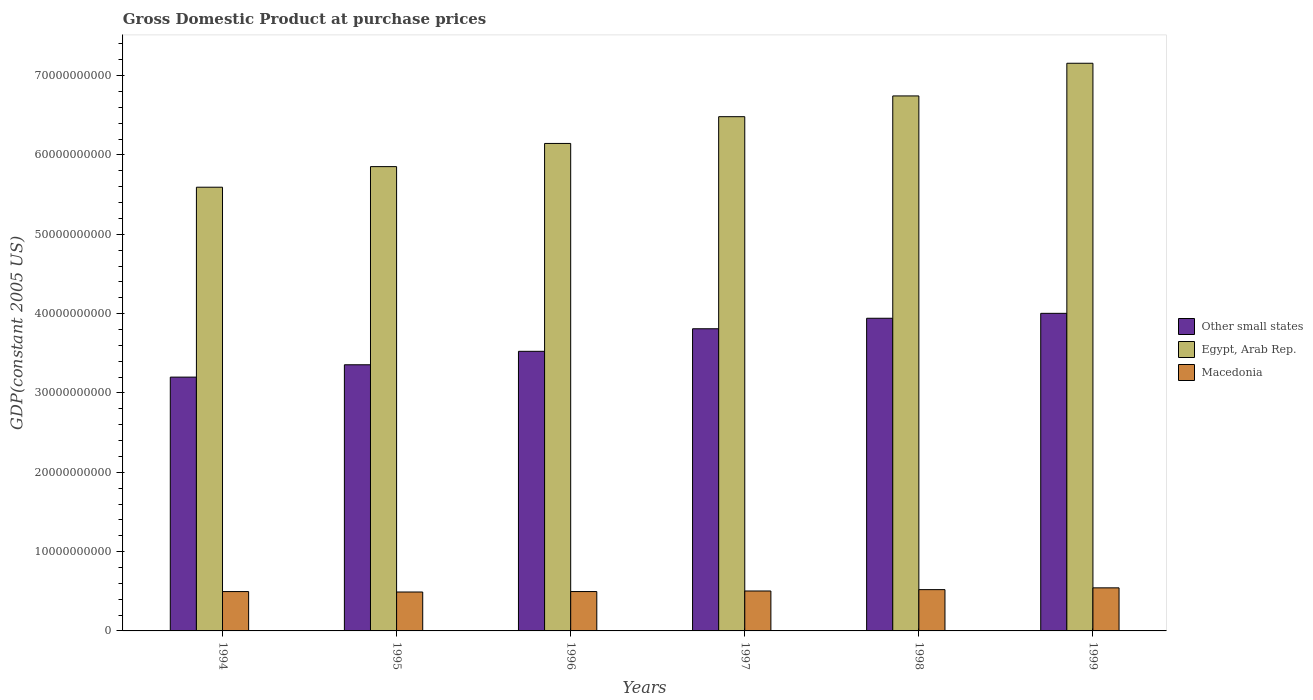How many different coloured bars are there?
Ensure brevity in your answer.  3. How many bars are there on the 3rd tick from the right?
Provide a short and direct response. 3. What is the label of the 4th group of bars from the left?
Keep it short and to the point. 1997. What is the GDP at purchase prices in Macedonia in 1999?
Offer a terse response. 5.43e+09. Across all years, what is the maximum GDP at purchase prices in Macedonia?
Give a very brief answer. 5.43e+09. Across all years, what is the minimum GDP at purchase prices in Other small states?
Give a very brief answer. 3.20e+1. In which year was the GDP at purchase prices in Macedonia minimum?
Keep it short and to the point. 1995. What is the total GDP at purchase prices in Macedonia in the graph?
Give a very brief answer. 3.05e+1. What is the difference between the GDP at purchase prices in Other small states in 1995 and that in 1996?
Provide a succinct answer. -1.70e+09. What is the difference between the GDP at purchase prices in Macedonia in 1999 and the GDP at purchase prices in Other small states in 1994?
Keep it short and to the point. -2.66e+1. What is the average GDP at purchase prices in Egypt, Arab Rep. per year?
Your answer should be compact. 6.33e+1. In the year 1998, what is the difference between the GDP at purchase prices in Macedonia and GDP at purchase prices in Other small states?
Offer a very short reply. -3.42e+1. In how many years, is the GDP at purchase prices in Macedonia greater than 66000000000 US$?
Ensure brevity in your answer.  0. What is the ratio of the GDP at purchase prices in Other small states in 1998 to that in 1999?
Make the answer very short. 0.98. Is the difference between the GDP at purchase prices in Macedonia in 1996 and 1998 greater than the difference between the GDP at purchase prices in Other small states in 1996 and 1998?
Provide a succinct answer. Yes. What is the difference between the highest and the second highest GDP at purchase prices in Egypt, Arab Rep.?
Give a very brief answer. 4.12e+09. What is the difference between the highest and the lowest GDP at purchase prices in Egypt, Arab Rep.?
Provide a succinct answer. 1.56e+1. What does the 1st bar from the left in 1995 represents?
Your response must be concise. Other small states. What does the 3rd bar from the right in 1995 represents?
Your answer should be compact. Other small states. Are all the bars in the graph horizontal?
Provide a short and direct response. No. How many years are there in the graph?
Give a very brief answer. 6. What is the difference between two consecutive major ticks on the Y-axis?
Provide a short and direct response. 1.00e+1. Are the values on the major ticks of Y-axis written in scientific E-notation?
Make the answer very short. No. Does the graph contain any zero values?
Your response must be concise. No. Where does the legend appear in the graph?
Offer a very short reply. Center right. How many legend labels are there?
Provide a succinct answer. 3. How are the legend labels stacked?
Your response must be concise. Vertical. What is the title of the graph?
Provide a short and direct response. Gross Domestic Product at purchase prices. Does "Cameroon" appear as one of the legend labels in the graph?
Provide a succinct answer. No. What is the label or title of the Y-axis?
Ensure brevity in your answer.  GDP(constant 2005 US). What is the GDP(constant 2005 US) of Other small states in 1994?
Offer a very short reply. 3.20e+1. What is the GDP(constant 2005 US) of Egypt, Arab Rep. in 1994?
Provide a short and direct response. 5.59e+1. What is the GDP(constant 2005 US) of Macedonia in 1994?
Your answer should be very brief. 4.96e+09. What is the GDP(constant 2005 US) in Other small states in 1995?
Provide a short and direct response. 3.36e+1. What is the GDP(constant 2005 US) of Egypt, Arab Rep. in 1995?
Ensure brevity in your answer.  5.85e+1. What is the GDP(constant 2005 US) of Macedonia in 1995?
Provide a succinct answer. 4.90e+09. What is the GDP(constant 2005 US) of Other small states in 1996?
Offer a very short reply. 3.52e+1. What is the GDP(constant 2005 US) of Egypt, Arab Rep. in 1996?
Offer a very short reply. 6.15e+1. What is the GDP(constant 2005 US) in Macedonia in 1996?
Make the answer very short. 4.96e+09. What is the GDP(constant 2005 US) of Other small states in 1997?
Keep it short and to the point. 3.81e+1. What is the GDP(constant 2005 US) of Egypt, Arab Rep. in 1997?
Provide a short and direct response. 6.48e+1. What is the GDP(constant 2005 US) of Macedonia in 1997?
Offer a terse response. 5.03e+09. What is the GDP(constant 2005 US) in Other small states in 1998?
Give a very brief answer. 3.94e+1. What is the GDP(constant 2005 US) of Egypt, Arab Rep. in 1998?
Keep it short and to the point. 6.74e+1. What is the GDP(constant 2005 US) of Macedonia in 1998?
Keep it short and to the point. 5.20e+09. What is the GDP(constant 2005 US) of Other small states in 1999?
Keep it short and to the point. 4.00e+1. What is the GDP(constant 2005 US) of Egypt, Arab Rep. in 1999?
Your answer should be compact. 7.16e+1. What is the GDP(constant 2005 US) of Macedonia in 1999?
Make the answer very short. 5.43e+09. Across all years, what is the maximum GDP(constant 2005 US) in Other small states?
Provide a short and direct response. 4.00e+1. Across all years, what is the maximum GDP(constant 2005 US) in Egypt, Arab Rep.?
Provide a short and direct response. 7.16e+1. Across all years, what is the maximum GDP(constant 2005 US) in Macedonia?
Provide a succinct answer. 5.43e+09. Across all years, what is the minimum GDP(constant 2005 US) of Other small states?
Offer a very short reply. 3.20e+1. Across all years, what is the minimum GDP(constant 2005 US) in Egypt, Arab Rep.?
Provide a short and direct response. 5.59e+1. Across all years, what is the minimum GDP(constant 2005 US) of Macedonia?
Give a very brief answer. 4.90e+09. What is the total GDP(constant 2005 US) in Other small states in the graph?
Provide a short and direct response. 2.18e+11. What is the total GDP(constant 2005 US) in Egypt, Arab Rep. in the graph?
Your answer should be very brief. 3.80e+11. What is the total GDP(constant 2005 US) of Macedonia in the graph?
Offer a very short reply. 3.05e+1. What is the difference between the GDP(constant 2005 US) of Other small states in 1994 and that in 1995?
Provide a succinct answer. -1.56e+09. What is the difference between the GDP(constant 2005 US) in Egypt, Arab Rep. in 1994 and that in 1995?
Your answer should be compact. -2.60e+09. What is the difference between the GDP(constant 2005 US) of Macedonia in 1994 and that in 1995?
Keep it short and to the point. 5.53e+07. What is the difference between the GDP(constant 2005 US) of Other small states in 1994 and that in 1996?
Your response must be concise. -3.25e+09. What is the difference between the GDP(constant 2005 US) of Egypt, Arab Rep. in 1994 and that in 1996?
Offer a very short reply. -5.52e+09. What is the difference between the GDP(constant 2005 US) of Macedonia in 1994 and that in 1996?
Give a very brief answer. -2.84e+06. What is the difference between the GDP(constant 2005 US) in Other small states in 1994 and that in 1997?
Ensure brevity in your answer.  -6.10e+09. What is the difference between the GDP(constant 2005 US) in Egypt, Arab Rep. in 1994 and that in 1997?
Your answer should be very brief. -8.89e+09. What is the difference between the GDP(constant 2005 US) of Macedonia in 1994 and that in 1997?
Give a very brief answer. -7.43e+07. What is the difference between the GDP(constant 2005 US) in Other small states in 1994 and that in 1998?
Your response must be concise. -7.42e+09. What is the difference between the GDP(constant 2005 US) in Egypt, Arab Rep. in 1994 and that in 1998?
Provide a short and direct response. -1.15e+1. What is the difference between the GDP(constant 2005 US) of Macedonia in 1994 and that in 1998?
Keep it short and to the point. -2.44e+08. What is the difference between the GDP(constant 2005 US) of Other small states in 1994 and that in 1999?
Make the answer very short. -8.04e+09. What is the difference between the GDP(constant 2005 US) of Egypt, Arab Rep. in 1994 and that in 1999?
Your answer should be very brief. -1.56e+1. What is the difference between the GDP(constant 2005 US) in Macedonia in 1994 and that in 1999?
Offer a terse response. -4.70e+08. What is the difference between the GDP(constant 2005 US) in Other small states in 1995 and that in 1996?
Make the answer very short. -1.70e+09. What is the difference between the GDP(constant 2005 US) of Egypt, Arab Rep. in 1995 and that in 1996?
Provide a succinct answer. -2.92e+09. What is the difference between the GDP(constant 2005 US) of Macedonia in 1995 and that in 1996?
Offer a very short reply. -5.81e+07. What is the difference between the GDP(constant 2005 US) in Other small states in 1995 and that in 1997?
Your response must be concise. -4.54e+09. What is the difference between the GDP(constant 2005 US) of Egypt, Arab Rep. in 1995 and that in 1997?
Ensure brevity in your answer.  -6.29e+09. What is the difference between the GDP(constant 2005 US) of Macedonia in 1995 and that in 1997?
Offer a terse response. -1.30e+08. What is the difference between the GDP(constant 2005 US) in Other small states in 1995 and that in 1998?
Offer a very short reply. -5.86e+09. What is the difference between the GDP(constant 2005 US) of Egypt, Arab Rep. in 1995 and that in 1998?
Make the answer very short. -8.91e+09. What is the difference between the GDP(constant 2005 US) in Macedonia in 1995 and that in 1998?
Offer a terse response. -3.00e+08. What is the difference between the GDP(constant 2005 US) in Other small states in 1995 and that in 1999?
Provide a short and direct response. -6.48e+09. What is the difference between the GDP(constant 2005 US) in Egypt, Arab Rep. in 1995 and that in 1999?
Make the answer very short. -1.30e+1. What is the difference between the GDP(constant 2005 US) in Macedonia in 1995 and that in 1999?
Make the answer very short. -5.26e+08. What is the difference between the GDP(constant 2005 US) in Other small states in 1996 and that in 1997?
Keep it short and to the point. -2.84e+09. What is the difference between the GDP(constant 2005 US) in Egypt, Arab Rep. in 1996 and that in 1997?
Your answer should be very brief. -3.37e+09. What is the difference between the GDP(constant 2005 US) in Macedonia in 1996 and that in 1997?
Keep it short and to the point. -7.15e+07. What is the difference between the GDP(constant 2005 US) of Other small states in 1996 and that in 1998?
Ensure brevity in your answer.  -4.17e+09. What is the difference between the GDP(constant 2005 US) in Egypt, Arab Rep. in 1996 and that in 1998?
Offer a very short reply. -5.99e+09. What is the difference between the GDP(constant 2005 US) of Macedonia in 1996 and that in 1998?
Your answer should be compact. -2.42e+08. What is the difference between the GDP(constant 2005 US) of Other small states in 1996 and that in 1999?
Give a very brief answer. -4.79e+09. What is the difference between the GDP(constant 2005 US) in Egypt, Arab Rep. in 1996 and that in 1999?
Make the answer very short. -1.01e+1. What is the difference between the GDP(constant 2005 US) in Macedonia in 1996 and that in 1999?
Give a very brief answer. -4.67e+08. What is the difference between the GDP(constant 2005 US) of Other small states in 1997 and that in 1998?
Your answer should be very brief. -1.32e+09. What is the difference between the GDP(constant 2005 US) of Egypt, Arab Rep. in 1997 and that in 1998?
Offer a very short reply. -2.62e+09. What is the difference between the GDP(constant 2005 US) of Macedonia in 1997 and that in 1998?
Ensure brevity in your answer.  -1.70e+08. What is the difference between the GDP(constant 2005 US) of Other small states in 1997 and that in 1999?
Your response must be concise. -1.94e+09. What is the difference between the GDP(constant 2005 US) of Egypt, Arab Rep. in 1997 and that in 1999?
Your response must be concise. -6.73e+09. What is the difference between the GDP(constant 2005 US) of Macedonia in 1997 and that in 1999?
Your answer should be compact. -3.96e+08. What is the difference between the GDP(constant 2005 US) in Other small states in 1998 and that in 1999?
Make the answer very short. -6.20e+08. What is the difference between the GDP(constant 2005 US) of Egypt, Arab Rep. in 1998 and that in 1999?
Your answer should be compact. -4.12e+09. What is the difference between the GDP(constant 2005 US) in Macedonia in 1998 and that in 1999?
Your answer should be compact. -2.26e+08. What is the difference between the GDP(constant 2005 US) in Other small states in 1994 and the GDP(constant 2005 US) in Egypt, Arab Rep. in 1995?
Provide a succinct answer. -2.65e+1. What is the difference between the GDP(constant 2005 US) in Other small states in 1994 and the GDP(constant 2005 US) in Macedonia in 1995?
Your answer should be very brief. 2.71e+1. What is the difference between the GDP(constant 2005 US) of Egypt, Arab Rep. in 1994 and the GDP(constant 2005 US) of Macedonia in 1995?
Give a very brief answer. 5.10e+1. What is the difference between the GDP(constant 2005 US) in Other small states in 1994 and the GDP(constant 2005 US) in Egypt, Arab Rep. in 1996?
Provide a short and direct response. -2.95e+1. What is the difference between the GDP(constant 2005 US) in Other small states in 1994 and the GDP(constant 2005 US) in Macedonia in 1996?
Offer a very short reply. 2.70e+1. What is the difference between the GDP(constant 2005 US) in Egypt, Arab Rep. in 1994 and the GDP(constant 2005 US) in Macedonia in 1996?
Give a very brief answer. 5.10e+1. What is the difference between the GDP(constant 2005 US) in Other small states in 1994 and the GDP(constant 2005 US) in Egypt, Arab Rep. in 1997?
Ensure brevity in your answer.  -3.28e+1. What is the difference between the GDP(constant 2005 US) in Other small states in 1994 and the GDP(constant 2005 US) in Macedonia in 1997?
Your response must be concise. 2.70e+1. What is the difference between the GDP(constant 2005 US) of Egypt, Arab Rep. in 1994 and the GDP(constant 2005 US) of Macedonia in 1997?
Keep it short and to the point. 5.09e+1. What is the difference between the GDP(constant 2005 US) in Other small states in 1994 and the GDP(constant 2005 US) in Egypt, Arab Rep. in 1998?
Make the answer very short. -3.54e+1. What is the difference between the GDP(constant 2005 US) in Other small states in 1994 and the GDP(constant 2005 US) in Macedonia in 1998?
Give a very brief answer. 2.68e+1. What is the difference between the GDP(constant 2005 US) in Egypt, Arab Rep. in 1994 and the GDP(constant 2005 US) in Macedonia in 1998?
Offer a very short reply. 5.07e+1. What is the difference between the GDP(constant 2005 US) of Other small states in 1994 and the GDP(constant 2005 US) of Egypt, Arab Rep. in 1999?
Ensure brevity in your answer.  -3.96e+1. What is the difference between the GDP(constant 2005 US) in Other small states in 1994 and the GDP(constant 2005 US) in Macedonia in 1999?
Ensure brevity in your answer.  2.66e+1. What is the difference between the GDP(constant 2005 US) in Egypt, Arab Rep. in 1994 and the GDP(constant 2005 US) in Macedonia in 1999?
Offer a terse response. 5.05e+1. What is the difference between the GDP(constant 2005 US) of Other small states in 1995 and the GDP(constant 2005 US) of Egypt, Arab Rep. in 1996?
Make the answer very short. -2.79e+1. What is the difference between the GDP(constant 2005 US) of Other small states in 1995 and the GDP(constant 2005 US) of Macedonia in 1996?
Your answer should be very brief. 2.86e+1. What is the difference between the GDP(constant 2005 US) in Egypt, Arab Rep. in 1995 and the GDP(constant 2005 US) in Macedonia in 1996?
Your answer should be very brief. 5.36e+1. What is the difference between the GDP(constant 2005 US) of Other small states in 1995 and the GDP(constant 2005 US) of Egypt, Arab Rep. in 1997?
Give a very brief answer. -3.13e+1. What is the difference between the GDP(constant 2005 US) in Other small states in 1995 and the GDP(constant 2005 US) in Macedonia in 1997?
Make the answer very short. 2.85e+1. What is the difference between the GDP(constant 2005 US) in Egypt, Arab Rep. in 1995 and the GDP(constant 2005 US) in Macedonia in 1997?
Your response must be concise. 5.35e+1. What is the difference between the GDP(constant 2005 US) in Other small states in 1995 and the GDP(constant 2005 US) in Egypt, Arab Rep. in 1998?
Offer a terse response. -3.39e+1. What is the difference between the GDP(constant 2005 US) in Other small states in 1995 and the GDP(constant 2005 US) in Macedonia in 1998?
Give a very brief answer. 2.83e+1. What is the difference between the GDP(constant 2005 US) of Egypt, Arab Rep. in 1995 and the GDP(constant 2005 US) of Macedonia in 1998?
Make the answer very short. 5.33e+1. What is the difference between the GDP(constant 2005 US) in Other small states in 1995 and the GDP(constant 2005 US) in Egypt, Arab Rep. in 1999?
Give a very brief answer. -3.80e+1. What is the difference between the GDP(constant 2005 US) in Other small states in 1995 and the GDP(constant 2005 US) in Macedonia in 1999?
Provide a succinct answer. 2.81e+1. What is the difference between the GDP(constant 2005 US) in Egypt, Arab Rep. in 1995 and the GDP(constant 2005 US) in Macedonia in 1999?
Your answer should be very brief. 5.31e+1. What is the difference between the GDP(constant 2005 US) of Other small states in 1996 and the GDP(constant 2005 US) of Egypt, Arab Rep. in 1997?
Your answer should be very brief. -2.96e+1. What is the difference between the GDP(constant 2005 US) of Other small states in 1996 and the GDP(constant 2005 US) of Macedonia in 1997?
Offer a very short reply. 3.02e+1. What is the difference between the GDP(constant 2005 US) in Egypt, Arab Rep. in 1996 and the GDP(constant 2005 US) in Macedonia in 1997?
Make the answer very short. 5.64e+1. What is the difference between the GDP(constant 2005 US) of Other small states in 1996 and the GDP(constant 2005 US) of Egypt, Arab Rep. in 1998?
Provide a succinct answer. -3.22e+1. What is the difference between the GDP(constant 2005 US) in Other small states in 1996 and the GDP(constant 2005 US) in Macedonia in 1998?
Your answer should be very brief. 3.00e+1. What is the difference between the GDP(constant 2005 US) in Egypt, Arab Rep. in 1996 and the GDP(constant 2005 US) in Macedonia in 1998?
Provide a succinct answer. 5.62e+1. What is the difference between the GDP(constant 2005 US) of Other small states in 1996 and the GDP(constant 2005 US) of Egypt, Arab Rep. in 1999?
Your answer should be compact. -3.63e+1. What is the difference between the GDP(constant 2005 US) in Other small states in 1996 and the GDP(constant 2005 US) in Macedonia in 1999?
Your answer should be compact. 2.98e+1. What is the difference between the GDP(constant 2005 US) of Egypt, Arab Rep. in 1996 and the GDP(constant 2005 US) of Macedonia in 1999?
Your answer should be very brief. 5.60e+1. What is the difference between the GDP(constant 2005 US) in Other small states in 1997 and the GDP(constant 2005 US) in Egypt, Arab Rep. in 1998?
Your response must be concise. -2.94e+1. What is the difference between the GDP(constant 2005 US) in Other small states in 1997 and the GDP(constant 2005 US) in Macedonia in 1998?
Keep it short and to the point. 3.29e+1. What is the difference between the GDP(constant 2005 US) of Egypt, Arab Rep. in 1997 and the GDP(constant 2005 US) of Macedonia in 1998?
Your answer should be very brief. 5.96e+1. What is the difference between the GDP(constant 2005 US) of Other small states in 1997 and the GDP(constant 2005 US) of Egypt, Arab Rep. in 1999?
Your answer should be compact. -3.35e+1. What is the difference between the GDP(constant 2005 US) of Other small states in 1997 and the GDP(constant 2005 US) of Macedonia in 1999?
Provide a short and direct response. 3.27e+1. What is the difference between the GDP(constant 2005 US) in Egypt, Arab Rep. in 1997 and the GDP(constant 2005 US) in Macedonia in 1999?
Keep it short and to the point. 5.94e+1. What is the difference between the GDP(constant 2005 US) of Other small states in 1998 and the GDP(constant 2005 US) of Egypt, Arab Rep. in 1999?
Provide a succinct answer. -3.21e+1. What is the difference between the GDP(constant 2005 US) in Other small states in 1998 and the GDP(constant 2005 US) in Macedonia in 1999?
Your response must be concise. 3.40e+1. What is the difference between the GDP(constant 2005 US) in Egypt, Arab Rep. in 1998 and the GDP(constant 2005 US) in Macedonia in 1999?
Your answer should be very brief. 6.20e+1. What is the average GDP(constant 2005 US) of Other small states per year?
Your response must be concise. 3.64e+1. What is the average GDP(constant 2005 US) of Egypt, Arab Rep. per year?
Provide a short and direct response. 6.33e+1. What is the average GDP(constant 2005 US) in Macedonia per year?
Offer a terse response. 5.08e+09. In the year 1994, what is the difference between the GDP(constant 2005 US) in Other small states and GDP(constant 2005 US) in Egypt, Arab Rep.?
Your answer should be compact. -2.39e+1. In the year 1994, what is the difference between the GDP(constant 2005 US) of Other small states and GDP(constant 2005 US) of Macedonia?
Offer a very short reply. 2.70e+1. In the year 1994, what is the difference between the GDP(constant 2005 US) in Egypt, Arab Rep. and GDP(constant 2005 US) in Macedonia?
Your answer should be very brief. 5.10e+1. In the year 1995, what is the difference between the GDP(constant 2005 US) in Other small states and GDP(constant 2005 US) in Egypt, Arab Rep.?
Make the answer very short. -2.50e+1. In the year 1995, what is the difference between the GDP(constant 2005 US) of Other small states and GDP(constant 2005 US) of Macedonia?
Your answer should be very brief. 2.86e+1. In the year 1995, what is the difference between the GDP(constant 2005 US) of Egypt, Arab Rep. and GDP(constant 2005 US) of Macedonia?
Ensure brevity in your answer.  5.36e+1. In the year 1996, what is the difference between the GDP(constant 2005 US) in Other small states and GDP(constant 2005 US) in Egypt, Arab Rep.?
Your response must be concise. -2.62e+1. In the year 1996, what is the difference between the GDP(constant 2005 US) in Other small states and GDP(constant 2005 US) in Macedonia?
Keep it short and to the point. 3.03e+1. In the year 1996, what is the difference between the GDP(constant 2005 US) in Egypt, Arab Rep. and GDP(constant 2005 US) in Macedonia?
Provide a short and direct response. 5.65e+1. In the year 1997, what is the difference between the GDP(constant 2005 US) in Other small states and GDP(constant 2005 US) in Egypt, Arab Rep.?
Provide a succinct answer. -2.67e+1. In the year 1997, what is the difference between the GDP(constant 2005 US) in Other small states and GDP(constant 2005 US) in Macedonia?
Your answer should be compact. 3.31e+1. In the year 1997, what is the difference between the GDP(constant 2005 US) of Egypt, Arab Rep. and GDP(constant 2005 US) of Macedonia?
Your answer should be very brief. 5.98e+1. In the year 1998, what is the difference between the GDP(constant 2005 US) in Other small states and GDP(constant 2005 US) in Egypt, Arab Rep.?
Provide a short and direct response. -2.80e+1. In the year 1998, what is the difference between the GDP(constant 2005 US) of Other small states and GDP(constant 2005 US) of Macedonia?
Your answer should be very brief. 3.42e+1. In the year 1998, what is the difference between the GDP(constant 2005 US) in Egypt, Arab Rep. and GDP(constant 2005 US) in Macedonia?
Offer a terse response. 6.22e+1. In the year 1999, what is the difference between the GDP(constant 2005 US) of Other small states and GDP(constant 2005 US) of Egypt, Arab Rep.?
Provide a short and direct response. -3.15e+1. In the year 1999, what is the difference between the GDP(constant 2005 US) in Other small states and GDP(constant 2005 US) in Macedonia?
Ensure brevity in your answer.  3.46e+1. In the year 1999, what is the difference between the GDP(constant 2005 US) of Egypt, Arab Rep. and GDP(constant 2005 US) of Macedonia?
Offer a terse response. 6.61e+1. What is the ratio of the GDP(constant 2005 US) of Other small states in 1994 to that in 1995?
Offer a very short reply. 0.95. What is the ratio of the GDP(constant 2005 US) of Egypt, Arab Rep. in 1994 to that in 1995?
Ensure brevity in your answer.  0.96. What is the ratio of the GDP(constant 2005 US) in Macedonia in 1994 to that in 1995?
Offer a terse response. 1.01. What is the ratio of the GDP(constant 2005 US) of Other small states in 1994 to that in 1996?
Ensure brevity in your answer.  0.91. What is the ratio of the GDP(constant 2005 US) of Egypt, Arab Rep. in 1994 to that in 1996?
Offer a terse response. 0.91. What is the ratio of the GDP(constant 2005 US) of Macedonia in 1994 to that in 1996?
Ensure brevity in your answer.  1. What is the ratio of the GDP(constant 2005 US) in Other small states in 1994 to that in 1997?
Ensure brevity in your answer.  0.84. What is the ratio of the GDP(constant 2005 US) in Egypt, Arab Rep. in 1994 to that in 1997?
Provide a succinct answer. 0.86. What is the ratio of the GDP(constant 2005 US) of Macedonia in 1994 to that in 1997?
Give a very brief answer. 0.99. What is the ratio of the GDP(constant 2005 US) of Other small states in 1994 to that in 1998?
Offer a terse response. 0.81. What is the ratio of the GDP(constant 2005 US) of Egypt, Arab Rep. in 1994 to that in 1998?
Your answer should be compact. 0.83. What is the ratio of the GDP(constant 2005 US) of Macedonia in 1994 to that in 1998?
Your response must be concise. 0.95. What is the ratio of the GDP(constant 2005 US) in Other small states in 1994 to that in 1999?
Ensure brevity in your answer.  0.8. What is the ratio of the GDP(constant 2005 US) in Egypt, Arab Rep. in 1994 to that in 1999?
Make the answer very short. 0.78. What is the ratio of the GDP(constant 2005 US) of Macedonia in 1994 to that in 1999?
Ensure brevity in your answer.  0.91. What is the ratio of the GDP(constant 2005 US) of Other small states in 1995 to that in 1996?
Keep it short and to the point. 0.95. What is the ratio of the GDP(constant 2005 US) of Egypt, Arab Rep. in 1995 to that in 1996?
Your answer should be compact. 0.95. What is the ratio of the GDP(constant 2005 US) in Macedonia in 1995 to that in 1996?
Provide a short and direct response. 0.99. What is the ratio of the GDP(constant 2005 US) of Other small states in 1995 to that in 1997?
Ensure brevity in your answer.  0.88. What is the ratio of the GDP(constant 2005 US) in Egypt, Arab Rep. in 1995 to that in 1997?
Your response must be concise. 0.9. What is the ratio of the GDP(constant 2005 US) in Macedonia in 1995 to that in 1997?
Provide a short and direct response. 0.97. What is the ratio of the GDP(constant 2005 US) of Other small states in 1995 to that in 1998?
Provide a short and direct response. 0.85. What is the ratio of the GDP(constant 2005 US) in Egypt, Arab Rep. in 1995 to that in 1998?
Your answer should be compact. 0.87. What is the ratio of the GDP(constant 2005 US) in Macedonia in 1995 to that in 1998?
Make the answer very short. 0.94. What is the ratio of the GDP(constant 2005 US) of Other small states in 1995 to that in 1999?
Provide a succinct answer. 0.84. What is the ratio of the GDP(constant 2005 US) of Egypt, Arab Rep. in 1995 to that in 1999?
Provide a short and direct response. 0.82. What is the ratio of the GDP(constant 2005 US) in Macedonia in 1995 to that in 1999?
Keep it short and to the point. 0.9. What is the ratio of the GDP(constant 2005 US) in Other small states in 1996 to that in 1997?
Make the answer very short. 0.93. What is the ratio of the GDP(constant 2005 US) in Egypt, Arab Rep. in 1996 to that in 1997?
Provide a short and direct response. 0.95. What is the ratio of the GDP(constant 2005 US) in Macedonia in 1996 to that in 1997?
Your answer should be very brief. 0.99. What is the ratio of the GDP(constant 2005 US) of Other small states in 1996 to that in 1998?
Keep it short and to the point. 0.89. What is the ratio of the GDP(constant 2005 US) in Egypt, Arab Rep. in 1996 to that in 1998?
Ensure brevity in your answer.  0.91. What is the ratio of the GDP(constant 2005 US) of Macedonia in 1996 to that in 1998?
Offer a terse response. 0.95. What is the ratio of the GDP(constant 2005 US) in Other small states in 1996 to that in 1999?
Provide a short and direct response. 0.88. What is the ratio of the GDP(constant 2005 US) in Egypt, Arab Rep. in 1996 to that in 1999?
Make the answer very short. 0.86. What is the ratio of the GDP(constant 2005 US) in Macedonia in 1996 to that in 1999?
Make the answer very short. 0.91. What is the ratio of the GDP(constant 2005 US) in Other small states in 1997 to that in 1998?
Provide a succinct answer. 0.97. What is the ratio of the GDP(constant 2005 US) in Egypt, Arab Rep. in 1997 to that in 1998?
Offer a terse response. 0.96. What is the ratio of the GDP(constant 2005 US) of Macedonia in 1997 to that in 1998?
Provide a succinct answer. 0.97. What is the ratio of the GDP(constant 2005 US) of Other small states in 1997 to that in 1999?
Give a very brief answer. 0.95. What is the ratio of the GDP(constant 2005 US) of Egypt, Arab Rep. in 1997 to that in 1999?
Offer a very short reply. 0.91. What is the ratio of the GDP(constant 2005 US) in Macedonia in 1997 to that in 1999?
Offer a very short reply. 0.93. What is the ratio of the GDP(constant 2005 US) of Other small states in 1998 to that in 1999?
Your response must be concise. 0.98. What is the ratio of the GDP(constant 2005 US) in Egypt, Arab Rep. in 1998 to that in 1999?
Your answer should be compact. 0.94. What is the ratio of the GDP(constant 2005 US) in Macedonia in 1998 to that in 1999?
Your response must be concise. 0.96. What is the difference between the highest and the second highest GDP(constant 2005 US) in Other small states?
Your answer should be compact. 6.20e+08. What is the difference between the highest and the second highest GDP(constant 2005 US) in Egypt, Arab Rep.?
Provide a succinct answer. 4.12e+09. What is the difference between the highest and the second highest GDP(constant 2005 US) in Macedonia?
Offer a very short reply. 2.26e+08. What is the difference between the highest and the lowest GDP(constant 2005 US) in Other small states?
Keep it short and to the point. 8.04e+09. What is the difference between the highest and the lowest GDP(constant 2005 US) of Egypt, Arab Rep.?
Ensure brevity in your answer.  1.56e+1. What is the difference between the highest and the lowest GDP(constant 2005 US) in Macedonia?
Make the answer very short. 5.26e+08. 